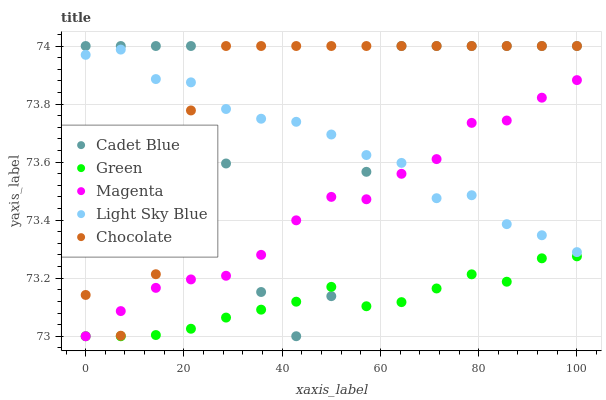Does Green have the minimum area under the curve?
Answer yes or no. Yes. Does Chocolate have the maximum area under the curve?
Answer yes or no. Yes. Does Cadet Blue have the minimum area under the curve?
Answer yes or no. No. Does Cadet Blue have the maximum area under the curve?
Answer yes or no. No. Is Green the smoothest?
Answer yes or no. Yes. Is Cadet Blue the roughest?
Answer yes or no. Yes. Is Cadet Blue the smoothest?
Answer yes or no. No. Is Green the roughest?
Answer yes or no. No. Does Magenta have the lowest value?
Answer yes or no. Yes. Does Cadet Blue have the lowest value?
Answer yes or no. No. Does Chocolate have the highest value?
Answer yes or no. Yes. Does Green have the highest value?
Answer yes or no. No. Is Green less than Light Sky Blue?
Answer yes or no. Yes. Is Light Sky Blue greater than Green?
Answer yes or no. Yes. Does Magenta intersect Cadet Blue?
Answer yes or no. Yes. Is Magenta less than Cadet Blue?
Answer yes or no. No. Is Magenta greater than Cadet Blue?
Answer yes or no. No. Does Green intersect Light Sky Blue?
Answer yes or no. No. 